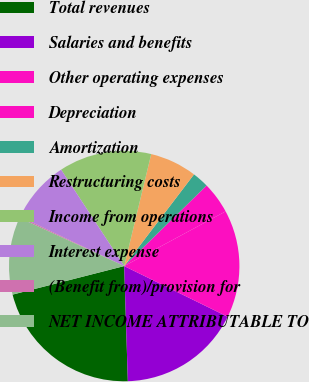Convert chart. <chart><loc_0><loc_0><loc_500><loc_500><pie_chart><fcel>Total revenues<fcel>Salaries and benefits<fcel>Other operating expenses<fcel>Depreciation<fcel>Amortization<fcel>Restructuring costs<fcel>Income from operations<fcel>Interest expense<fcel>(Benefit from)/provision for<fcel>NET INCOME ATTRIBUTABLE TO<nl><fcel>21.52%<fcel>17.25%<fcel>15.12%<fcel>4.45%<fcel>2.32%<fcel>6.59%<fcel>12.99%<fcel>8.72%<fcel>0.19%<fcel>10.85%<nl></chart> 